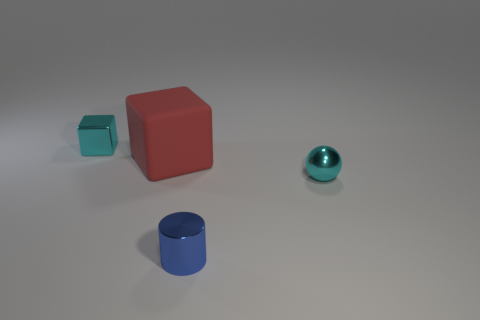Is there any other thing that has the same material as the big red cube?
Your answer should be very brief. No. What shape is the shiny thing that is the same color as the shiny sphere?
Ensure brevity in your answer.  Cube. How many rubber things are big cyan spheres or big red things?
Make the answer very short. 1. Are there any other things that are the same size as the rubber object?
Your response must be concise. No. Do the cyan metallic block and the block to the right of the metallic block have the same size?
Make the answer very short. No. What is the shape of the small thing left of the blue cylinder?
Provide a succinct answer. Cube. What color is the cube in front of the small metal cube that is behind the cyan metallic ball?
Your answer should be very brief. Red. There is a tiny thing that is the same shape as the large red object; what color is it?
Provide a succinct answer. Cyan. How many cubes have the same color as the big matte object?
Keep it short and to the point. 0. There is a shiny cube; is it the same color as the sphere right of the red rubber cube?
Your answer should be compact. Yes. 